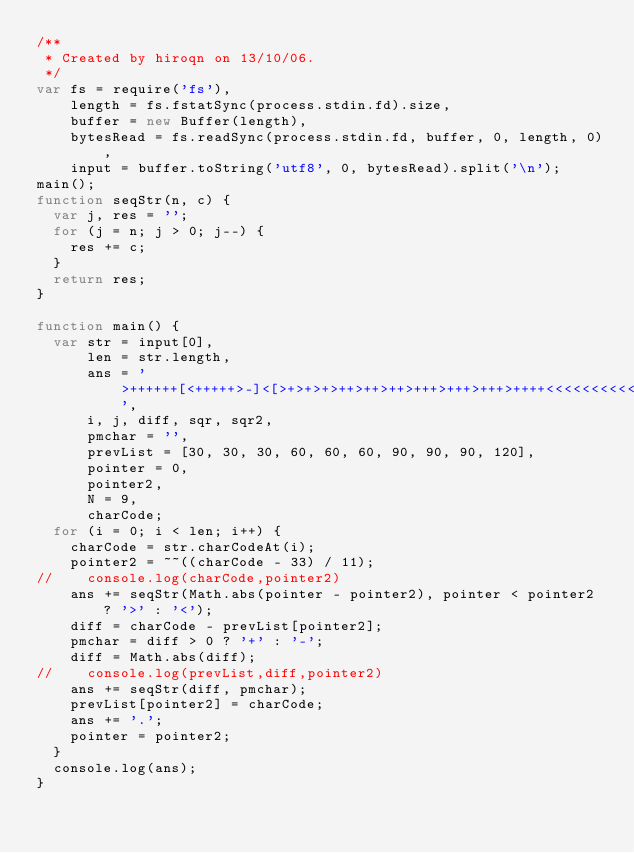Convert code to text. <code><loc_0><loc_0><loc_500><loc_500><_JavaScript_>/**
 * Created by hiroqn on 13/10/06.
 */
var fs = require('fs'),
    length = fs.fstatSync(process.stdin.fd).size,
    buffer = new Buffer(length),
    bytesRead = fs.readSync(process.stdin.fd, buffer, 0, length, 0),
    input = buffer.toString('utf8', 0, bytesRead).split('\n');
main();
function seqStr(n, c) {
  var j, res = '';
  for (j = n; j > 0; j--) {
    res += c;
  }
  return res;
}

function main() {
  var str = input[0],
      len = str.length,
      ans = '>++++++[<+++++>-]<[>+>+>+>++>++>++>+++>+++>+++>++++<<<<<<<<<<-]>',
      i, j, diff, sqr, sqr2,
      pmchar = '',
      prevList = [30, 30, 30, 60, 60, 60, 90, 90, 90, 120],
      pointer = 0,
      pointer2,
      N = 9,
      charCode;
  for (i = 0; i < len; i++) {
    charCode = str.charCodeAt(i);
    pointer2 = ~~((charCode - 33) / 11);
//    console.log(charCode,pointer2)
    ans += seqStr(Math.abs(pointer - pointer2), pointer < pointer2 ? '>' : '<');
    diff = charCode - prevList[pointer2];
    pmchar = diff > 0 ? '+' : '-';
    diff = Math.abs(diff);
//    console.log(prevList,diff,pointer2)
    ans += seqStr(diff, pmchar);
    prevList[pointer2] = charCode;
    ans += '.';
    pointer = pointer2;
  }
  console.log(ans);
}</code> 